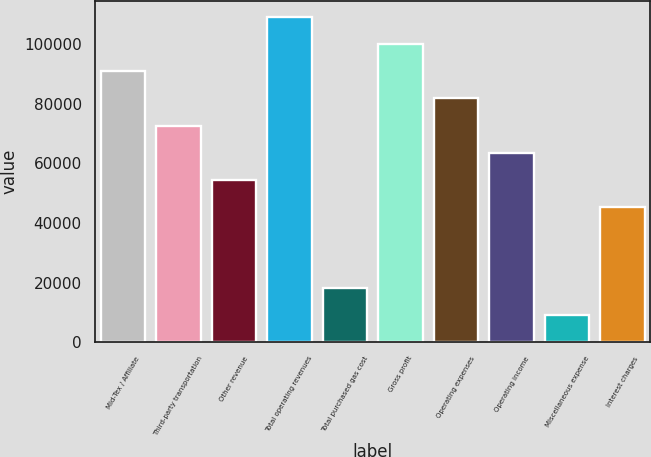Convert chart to OTSL. <chart><loc_0><loc_0><loc_500><loc_500><bar_chart><fcel>Mid-Tex / Affiliate<fcel>Third-party transportation<fcel>Other revenue<fcel>Total operating revenues<fcel>Total purchased gas cost<fcel>Gross profit<fcel>Operating expenses<fcel>Operating income<fcel>Miscellaneous expense<fcel>Interest charges<nl><fcel>90876<fcel>72713<fcel>54550<fcel>109039<fcel>18224<fcel>99957.5<fcel>81794.5<fcel>63631.5<fcel>9142.5<fcel>45468.5<nl></chart> 